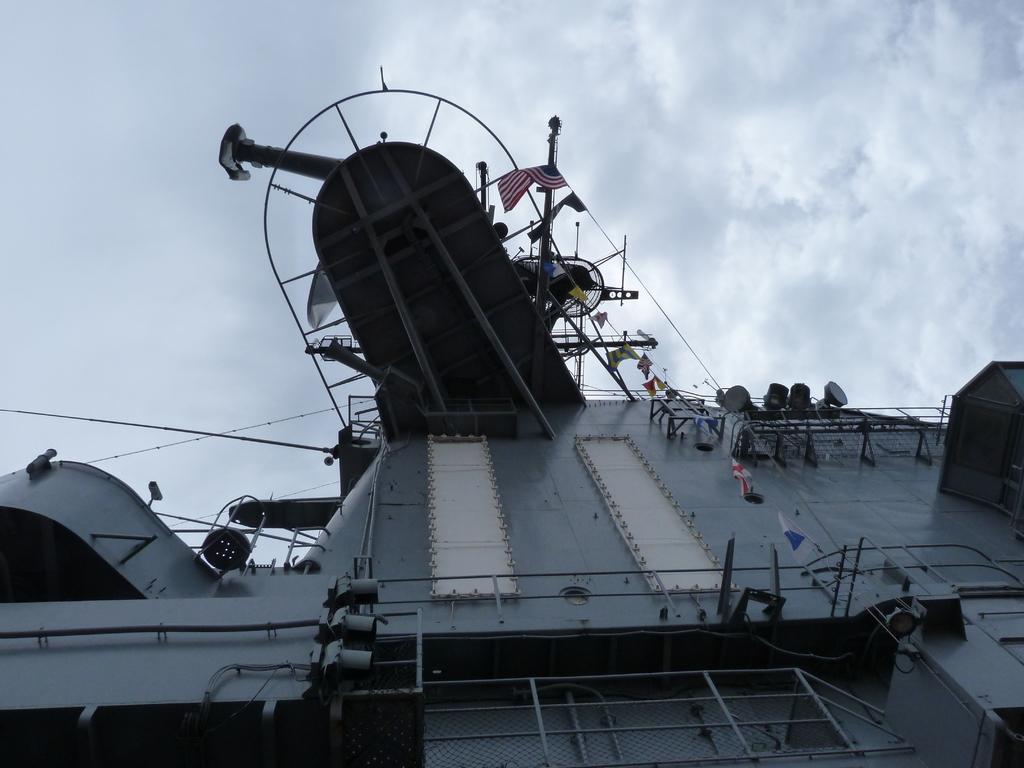Could you give a brief overview of what you see in this image? In this image at the bottom there is one boat and on the right side there is a rope and some flags, which are hanging and on the top of the image there is some machine and some pipes. On the top of the image there is sky. 